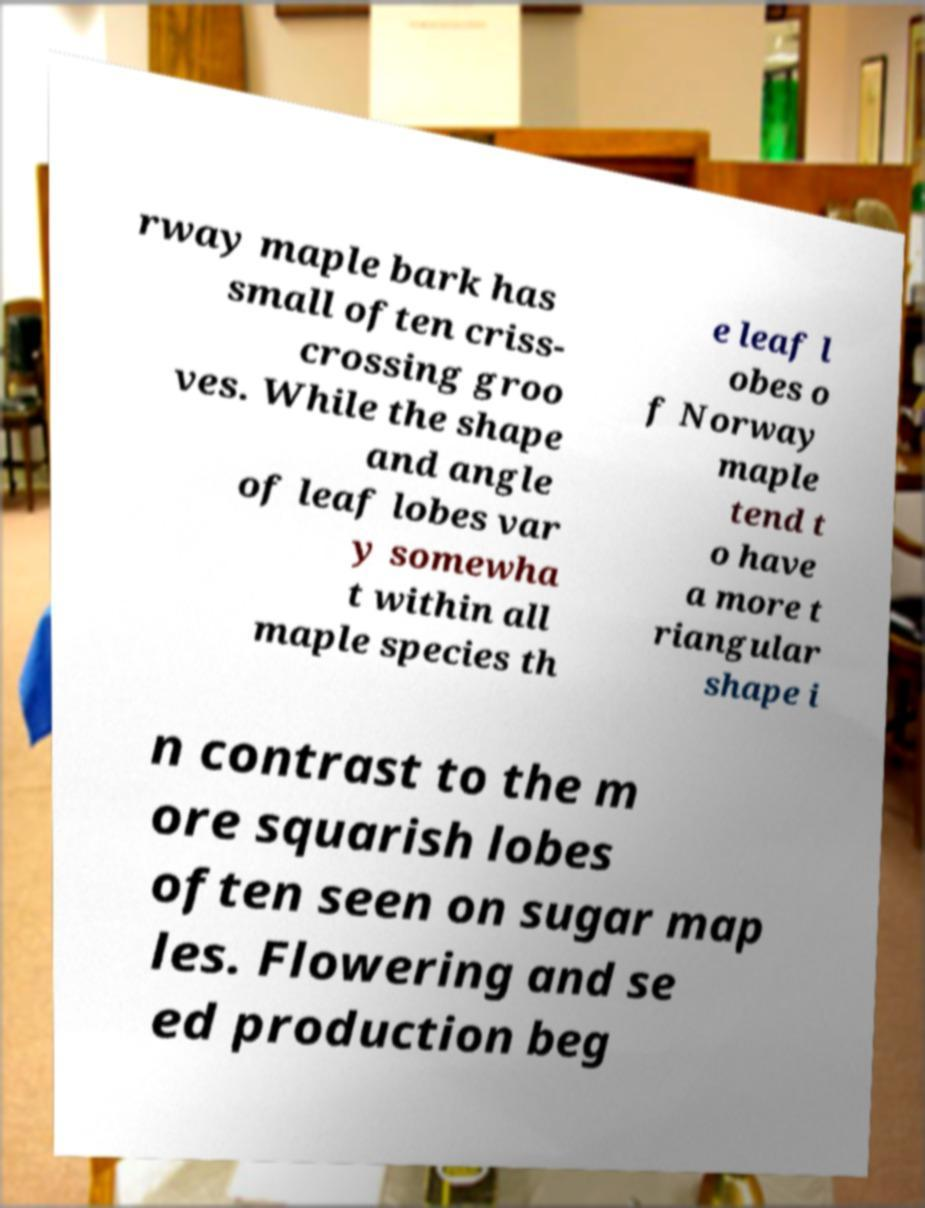Can you read and provide the text displayed in the image?This photo seems to have some interesting text. Can you extract and type it out for me? rway maple bark has small often criss- crossing groo ves. While the shape and angle of leaf lobes var y somewha t within all maple species th e leaf l obes o f Norway maple tend t o have a more t riangular shape i n contrast to the m ore squarish lobes often seen on sugar map les. Flowering and se ed production beg 